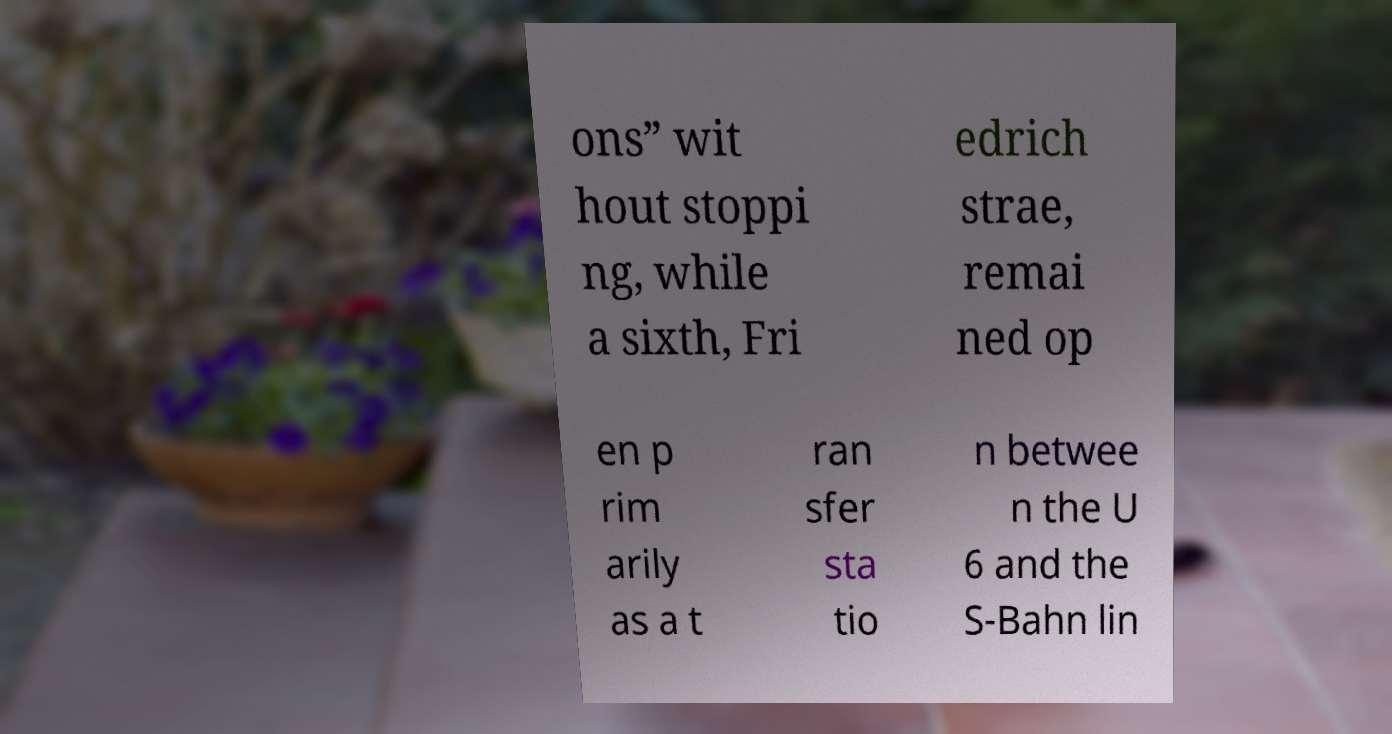What messages or text are displayed in this image? I need them in a readable, typed format. ons” wit hout stoppi ng, while a sixth, Fri edrich strae, remai ned op en p rim arily as a t ran sfer sta tio n betwee n the U 6 and the S-Bahn lin 